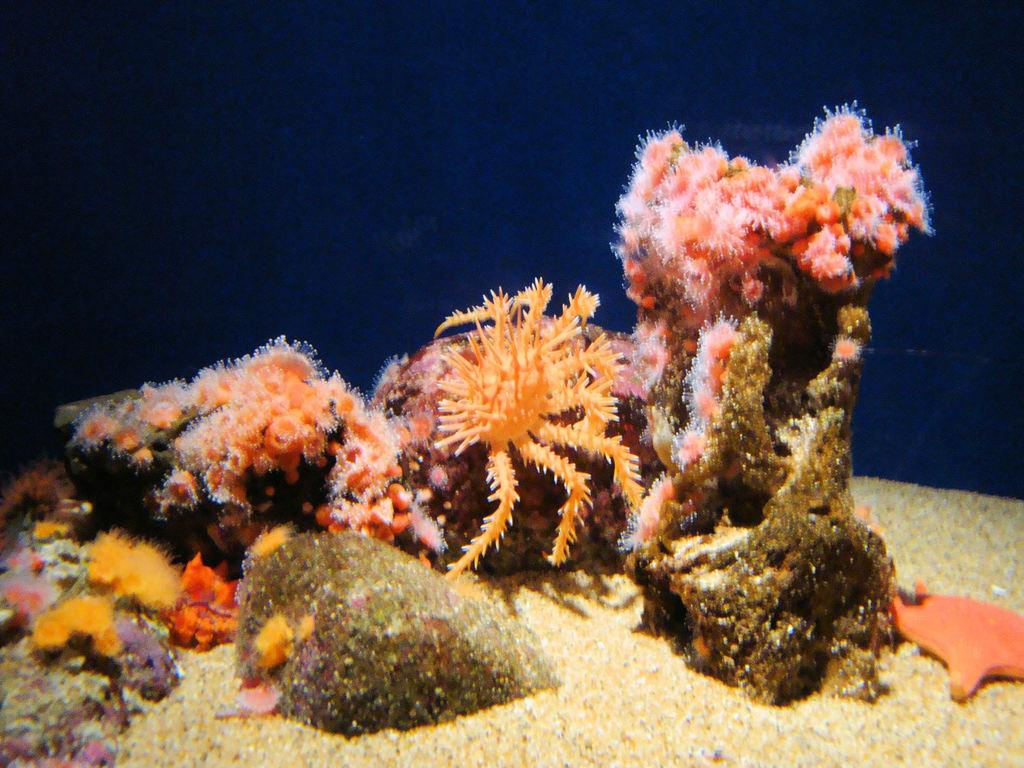What type of animals can be seen in the image? There are aquatic animals in the image. What other elements are present in the image besides the animals? There are stones and sand visible in the image. What color is the background of the image? The background color is blue. What type of hat is the fish wearing in the image? There are no hats present in the image, as the animals depicted are aquatic and do not wear clothing. 